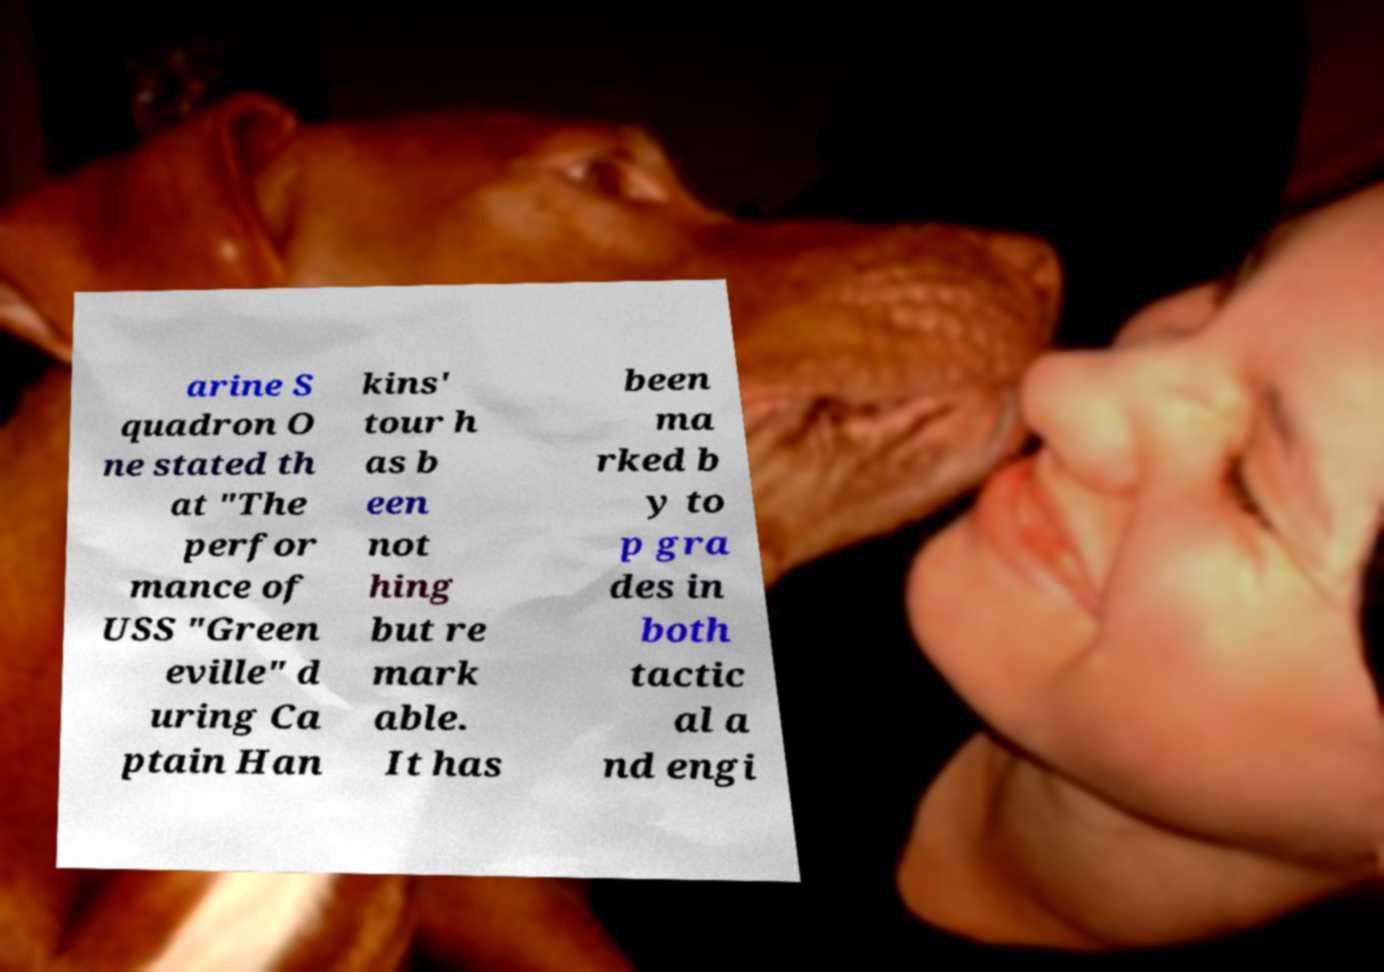Can you accurately transcribe the text from the provided image for me? arine S quadron O ne stated th at "The perfor mance of USS "Green eville" d uring Ca ptain Han kins' tour h as b een not hing but re mark able. It has been ma rked b y to p gra des in both tactic al a nd engi 